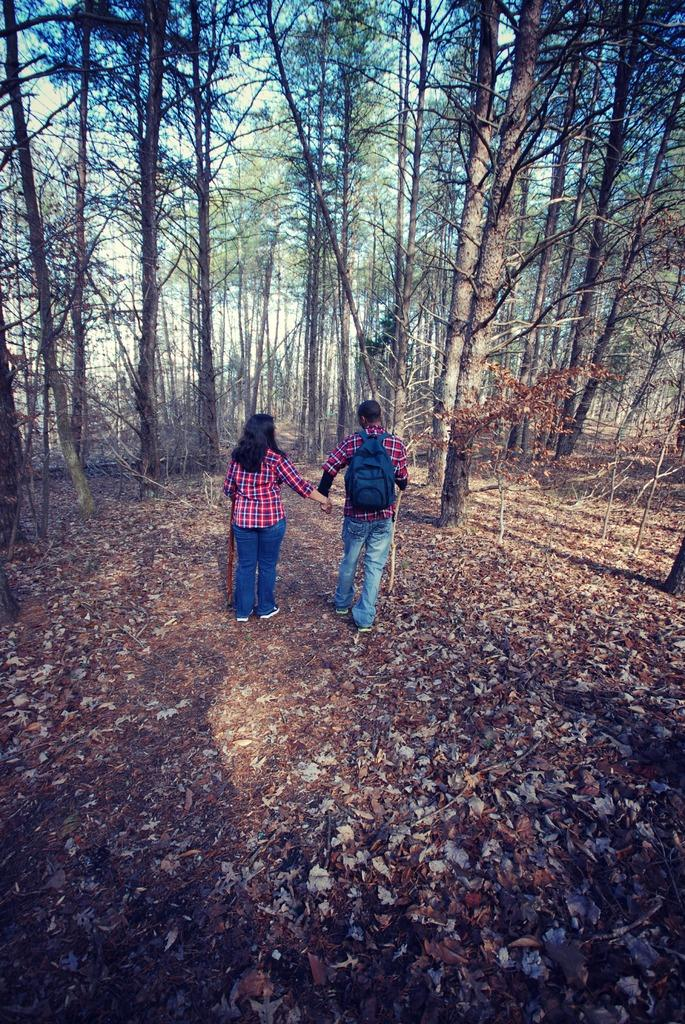What type of natural material can be seen in the image? There are dry leaves in the image. What are the people wearing in the image? Two people are wearing red color shirts in the image. What type of vegetation is present in the image? There are trees in the image. What is visible in the background of the image? The sky is visible in the image. What is the person wearing on their back in the image? There is a person wearing a bag in the image. Can you tell me how many bridges are visible in the image? There are no bridges present in the image. What type of arithmetic problem is being solved by the person in the image? There is no arithmetic problem being solved in the image; it features people and trees. 